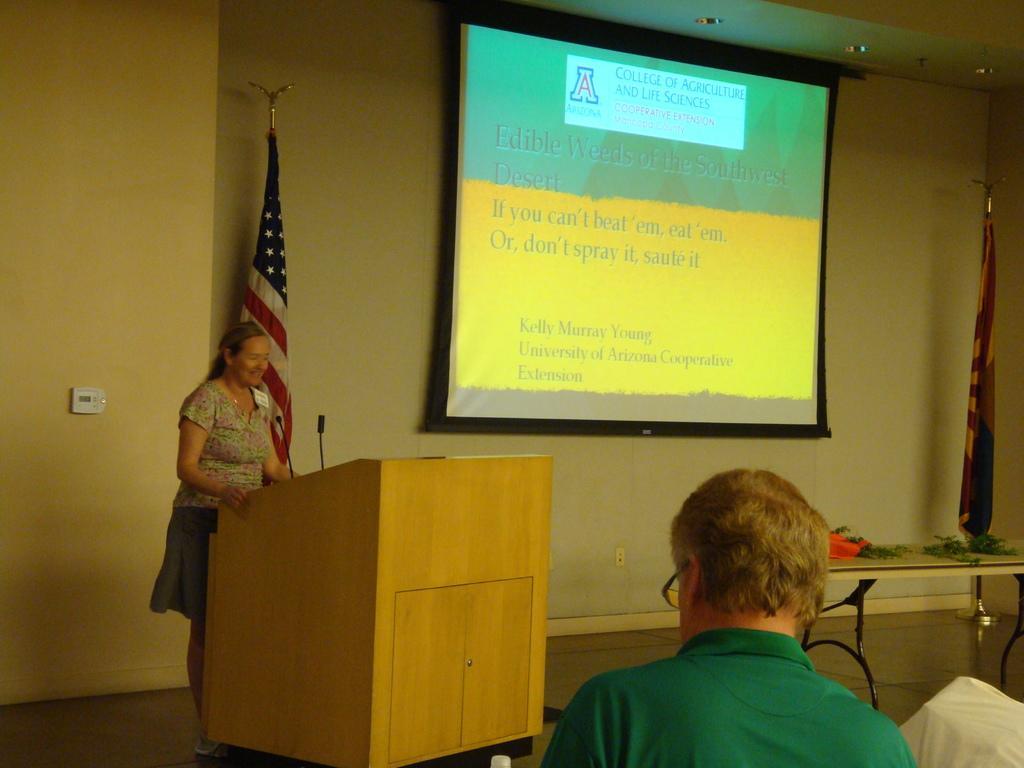In one or two sentences, can you explain what this image depicts? In this image I can see woman standing in front of podium and I can see a mice. I can see a screen,table and cream wall. In front I can see a person. 